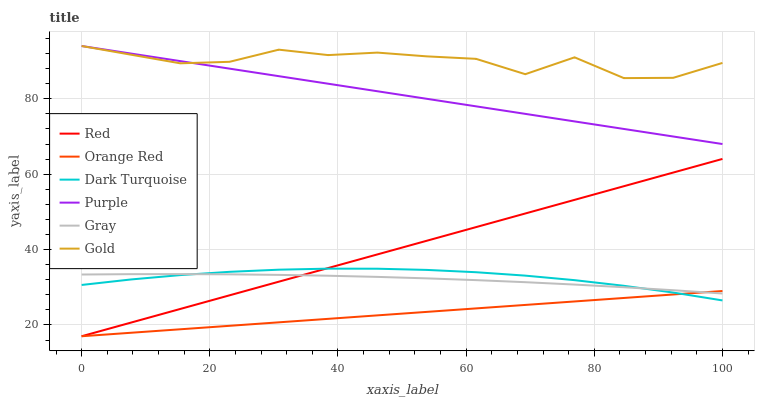Does Orange Red have the minimum area under the curve?
Answer yes or no. Yes. Does Gold have the maximum area under the curve?
Answer yes or no. Yes. Does Purple have the minimum area under the curve?
Answer yes or no. No. Does Purple have the maximum area under the curve?
Answer yes or no. No. Is Orange Red the smoothest?
Answer yes or no. Yes. Is Gold the roughest?
Answer yes or no. Yes. Is Purple the smoothest?
Answer yes or no. No. Is Purple the roughest?
Answer yes or no. No. Does Orange Red have the lowest value?
Answer yes or no. Yes. Does Purple have the lowest value?
Answer yes or no. No. Does Purple have the highest value?
Answer yes or no. Yes. Does Dark Turquoise have the highest value?
Answer yes or no. No. Is Gray less than Purple?
Answer yes or no. Yes. Is Gold greater than Dark Turquoise?
Answer yes or no. Yes. Does Orange Red intersect Dark Turquoise?
Answer yes or no. Yes. Is Orange Red less than Dark Turquoise?
Answer yes or no. No. Is Orange Red greater than Dark Turquoise?
Answer yes or no. No. Does Gray intersect Purple?
Answer yes or no. No. 